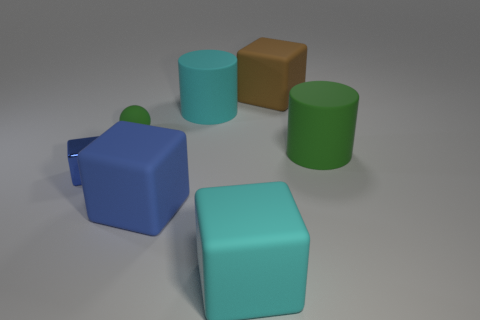Is there anything else that is made of the same material as the small blue cube?
Make the answer very short. No. There is a small blue cube; what number of small green objects are in front of it?
Make the answer very short. 0. There is a blue metallic object that is the same shape as the big brown thing; what is its size?
Offer a very short reply. Small. There is a object that is in front of the cyan matte cylinder and on the right side of the cyan cube; what is its size?
Give a very brief answer. Large. Do the metal cube and the rubber thing right of the brown cube have the same color?
Your response must be concise. No. How many red things are either matte cylinders or matte things?
Your response must be concise. 0. The small green object is what shape?
Your answer should be very brief. Sphere. How many other things are the same shape as the tiny shiny object?
Provide a short and direct response. 3. There is a large rubber cube that is behind the big blue object; what is its color?
Give a very brief answer. Brown. Do the cyan cylinder and the big green cylinder have the same material?
Your answer should be compact. Yes. 